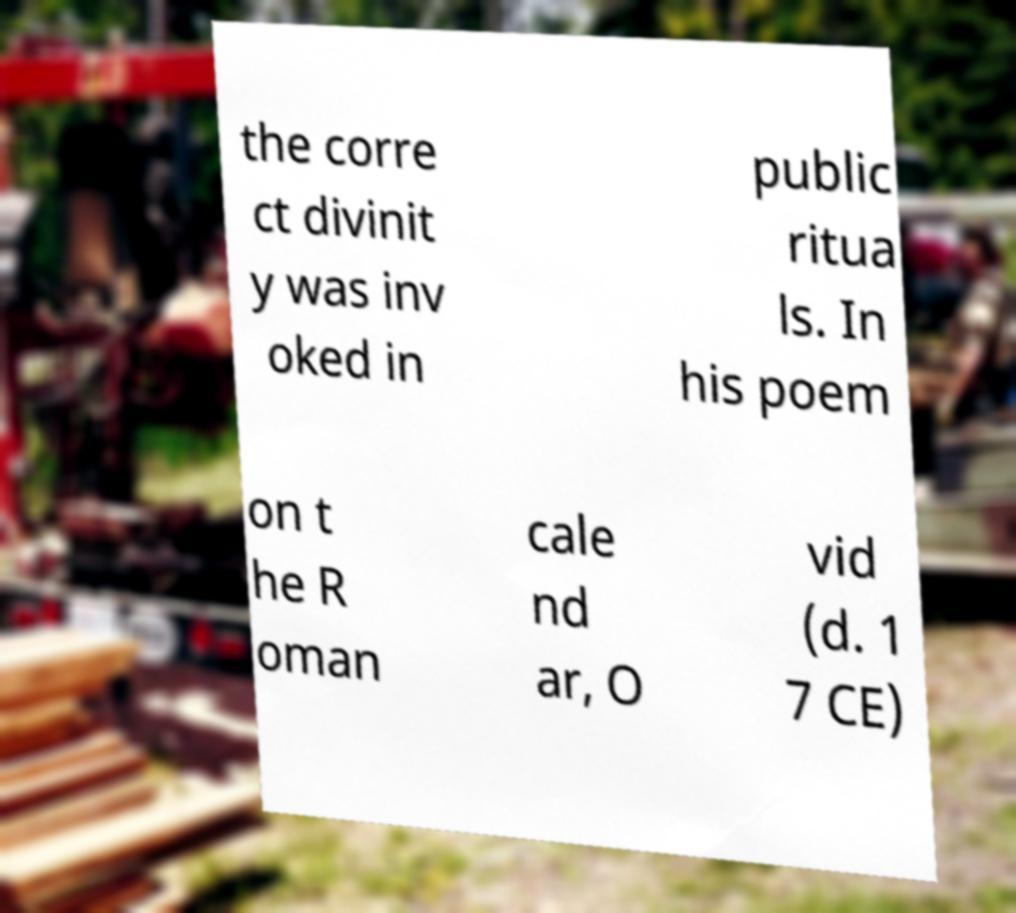I need the written content from this picture converted into text. Can you do that? the corre ct divinit y was inv oked in public ritua ls. In his poem on t he R oman cale nd ar, O vid (d. 1 7 CE) 